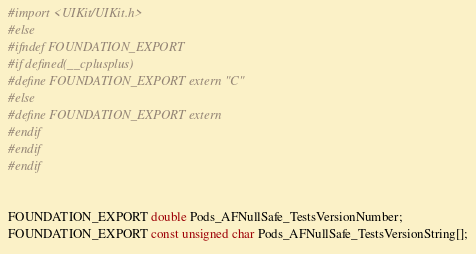Convert code to text. <code><loc_0><loc_0><loc_500><loc_500><_C_>#import <UIKit/UIKit.h>
#else
#ifndef FOUNDATION_EXPORT
#if defined(__cplusplus)
#define FOUNDATION_EXPORT extern "C"
#else
#define FOUNDATION_EXPORT extern
#endif
#endif
#endif


FOUNDATION_EXPORT double Pods_AFNullSafe_TestsVersionNumber;
FOUNDATION_EXPORT const unsigned char Pods_AFNullSafe_TestsVersionString[];

</code> 